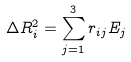<formula> <loc_0><loc_0><loc_500><loc_500>\Delta R _ { i } ^ { 2 } = \sum _ { j = 1 } ^ { 3 } r _ { i j } E _ { j }</formula> 